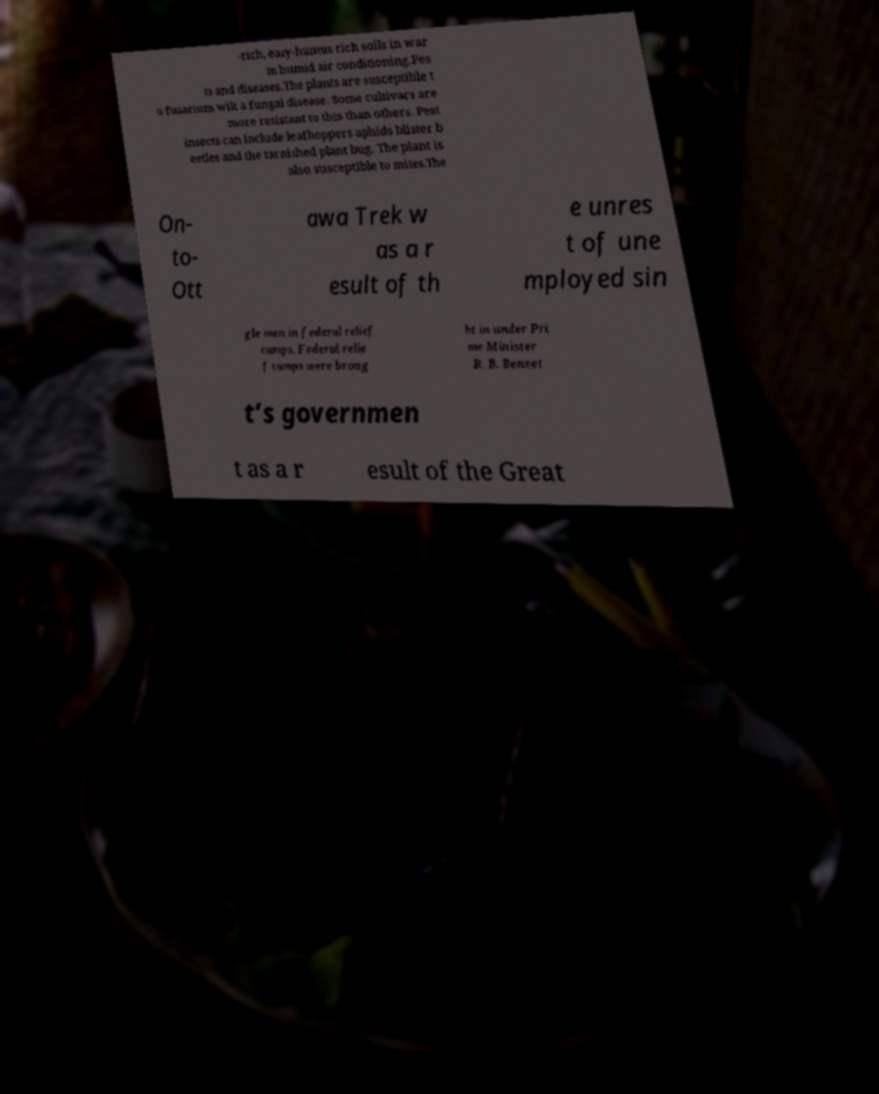Could you extract and type out the text from this image? -rich, easy-humus rich soils in war m humid air conditioning.Pes ts and diseases.The plants are susceptible t o fusarium wilt a fungal disease. Some cultivars are more resistant to this than others. Pest insects can include leafhoppers aphids blister b eetles and the tarnished plant bug. The plant is also susceptible to mites.The On- to- Ott awa Trek w as a r esult of th e unres t of une mployed sin gle men in federal relief camps. Federal relie f camps were broug ht in under Pri me Minister R. B. Bennet t’s governmen t as a r esult of the Great 